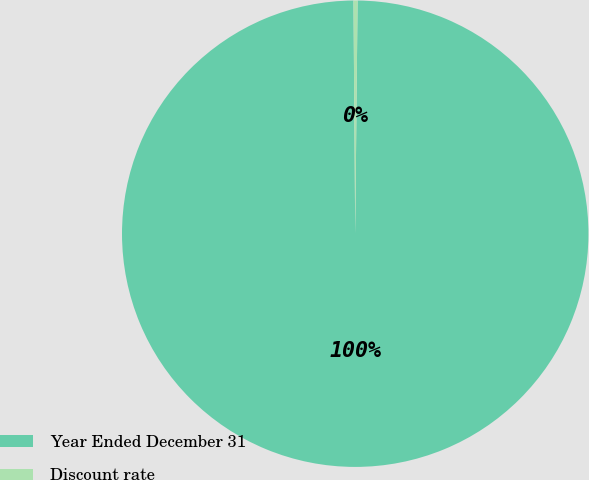<chart> <loc_0><loc_0><loc_500><loc_500><pie_chart><fcel>Year Ended December 31<fcel>Discount rate<nl><fcel>99.72%<fcel>0.28%<nl></chart> 